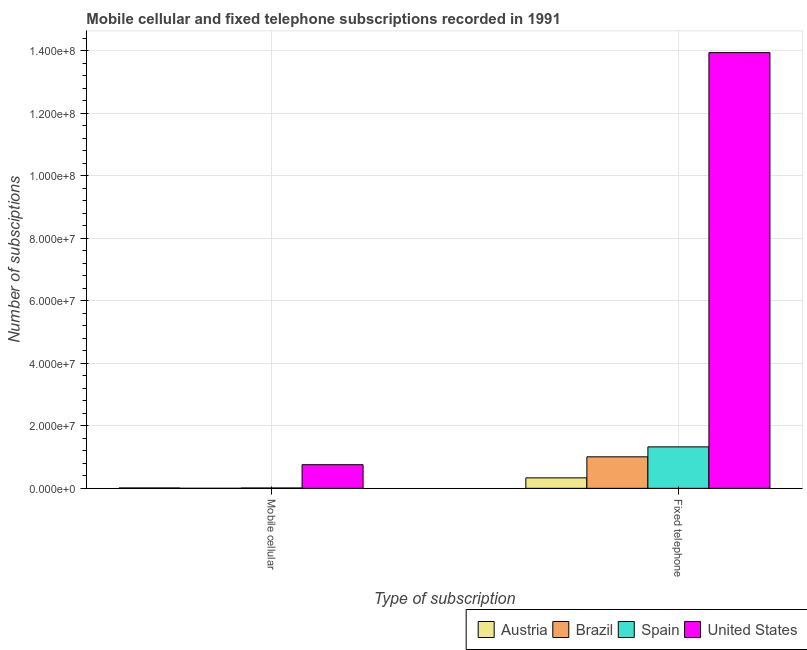Are the number of bars per tick equal to the number of legend labels?
Provide a short and direct response. Yes. Are the number of bars on each tick of the X-axis equal?
Your answer should be very brief. Yes. How many bars are there on the 2nd tick from the left?
Ensure brevity in your answer.  4. What is the label of the 1st group of bars from the left?
Offer a very short reply. Mobile cellular. What is the number of fixed telephone subscriptions in United States?
Your answer should be compact. 1.39e+08. Across all countries, what is the maximum number of fixed telephone subscriptions?
Your response must be concise. 1.39e+08. Across all countries, what is the minimum number of fixed telephone subscriptions?
Ensure brevity in your answer.  3.34e+06. In which country was the number of mobile cellular subscriptions maximum?
Make the answer very short. United States. In which country was the number of fixed telephone subscriptions minimum?
Provide a succinct answer. Austria. What is the total number of fixed telephone subscriptions in the graph?
Provide a short and direct response. 1.66e+08. What is the difference between the number of fixed telephone subscriptions in Austria and that in United States?
Give a very brief answer. -1.36e+08. What is the difference between the number of fixed telephone subscriptions in Spain and the number of mobile cellular subscriptions in United States?
Provide a succinct answer. 5.71e+06. What is the average number of mobile cellular subscriptions per country?
Keep it short and to the point. 1.95e+06. What is the difference between the number of mobile cellular subscriptions and number of fixed telephone subscriptions in United States?
Your response must be concise. -1.32e+08. What is the ratio of the number of fixed telephone subscriptions in Spain to that in Brazil?
Make the answer very short. 1.32. What does the 4th bar from the right in Fixed telephone represents?
Your answer should be very brief. Austria. How many countries are there in the graph?
Keep it short and to the point. 4. Does the graph contain any zero values?
Offer a terse response. No. How many legend labels are there?
Make the answer very short. 4. How are the legend labels stacked?
Make the answer very short. Horizontal. What is the title of the graph?
Your answer should be very brief. Mobile cellular and fixed telephone subscriptions recorded in 1991. Does "Brunei Darussalam" appear as one of the legend labels in the graph?
Your response must be concise. No. What is the label or title of the X-axis?
Provide a short and direct response. Type of subscription. What is the label or title of the Y-axis?
Give a very brief answer. Number of subsciptions. What is the Number of subsciptions in Austria in Mobile cellular?
Your answer should be compact. 1.15e+05. What is the Number of subsciptions of Brazil in Mobile cellular?
Ensure brevity in your answer.  6700. What is the Number of subsciptions in Spain in Mobile cellular?
Give a very brief answer. 1.08e+05. What is the Number of subsciptions of United States in Mobile cellular?
Provide a short and direct response. 7.56e+06. What is the Number of subsciptions of Austria in Fixed telephone?
Give a very brief answer. 3.34e+06. What is the Number of subsciptions of Brazil in Fixed telephone?
Ensure brevity in your answer.  1.01e+07. What is the Number of subsciptions in Spain in Fixed telephone?
Your answer should be compact. 1.33e+07. What is the Number of subsciptions in United States in Fixed telephone?
Your answer should be compact. 1.39e+08. Across all Type of subscription, what is the maximum Number of subsciptions in Austria?
Provide a short and direct response. 3.34e+06. Across all Type of subscription, what is the maximum Number of subsciptions in Brazil?
Provide a succinct answer. 1.01e+07. Across all Type of subscription, what is the maximum Number of subsciptions of Spain?
Your answer should be very brief. 1.33e+07. Across all Type of subscription, what is the maximum Number of subsciptions of United States?
Make the answer very short. 1.39e+08. Across all Type of subscription, what is the minimum Number of subsciptions in Austria?
Keep it short and to the point. 1.15e+05. Across all Type of subscription, what is the minimum Number of subsciptions of Brazil?
Make the answer very short. 6700. Across all Type of subscription, what is the minimum Number of subsciptions in Spain?
Provide a succinct answer. 1.08e+05. Across all Type of subscription, what is the minimum Number of subsciptions in United States?
Your answer should be very brief. 7.56e+06. What is the total Number of subsciptions in Austria in the graph?
Offer a terse response. 3.46e+06. What is the total Number of subsciptions in Brazil in the graph?
Your response must be concise. 1.01e+07. What is the total Number of subsciptions in Spain in the graph?
Provide a succinct answer. 1.34e+07. What is the total Number of subsciptions of United States in the graph?
Ensure brevity in your answer.  1.47e+08. What is the difference between the Number of subsciptions of Austria in Mobile cellular and that in Fixed telephone?
Your response must be concise. -3.23e+06. What is the difference between the Number of subsciptions of Brazil in Mobile cellular and that in Fixed telephone?
Your answer should be very brief. -1.01e+07. What is the difference between the Number of subsciptions of Spain in Mobile cellular and that in Fixed telephone?
Offer a very short reply. -1.32e+07. What is the difference between the Number of subsciptions in United States in Mobile cellular and that in Fixed telephone?
Your response must be concise. -1.32e+08. What is the difference between the Number of subsciptions in Austria in Mobile cellular and the Number of subsciptions in Brazil in Fixed telephone?
Provide a succinct answer. -9.96e+06. What is the difference between the Number of subsciptions of Austria in Mobile cellular and the Number of subsciptions of Spain in Fixed telephone?
Give a very brief answer. -1.31e+07. What is the difference between the Number of subsciptions in Austria in Mobile cellular and the Number of subsciptions in United States in Fixed telephone?
Offer a terse response. -1.39e+08. What is the difference between the Number of subsciptions in Brazil in Mobile cellular and the Number of subsciptions in Spain in Fixed telephone?
Your answer should be very brief. -1.33e+07. What is the difference between the Number of subsciptions of Brazil in Mobile cellular and the Number of subsciptions of United States in Fixed telephone?
Ensure brevity in your answer.  -1.39e+08. What is the difference between the Number of subsciptions of Spain in Mobile cellular and the Number of subsciptions of United States in Fixed telephone?
Your response must be concise. -1.39e+08. What is the average Number of subsciptions of Austria per Type of subscription?
Your response must be concise. 1.73e+06. What is the average Number of subsciptions in Brazil per Type of subscription?
Keep it short and to the point. 5.04e+06. What is the average Number of subsciptions in Spain per Type of subscription?
Your response must be concise. 6.69e+06. What is the average Number of subsciptions in United States per Type of subscription?
Your answer should be compact. 7.35e+07. What is the difference between the Number of subsciptions of Austria and Number of subsciptions of Brazil in Mobile cellular?
Provide a succinct answer. 1.09e+05. What is the difference between the Number of subsciptions of Austria and Number of subsciptions of Spain in Mobile cellular?
Give a very brief answer. 6951. What is the difference between the Number of subsciptions of Austria and Number of subsciptions of United States in Mobile cellular?
Make the answer very short. -7.44e+06. What is the difference between the Number of subsciptions in Brazil and Number of subsciptions in Spain in Mobile cellular?
Keep it short and to the point. -1.02e+05. What is the difference between the Number of subsciptions in Brazil and Number of subsciptions in United States in Mobile cellular?
Offer a terse response. -7.55e+06. What is the difference between the Number of subsciptions in Spain and Number of subsciptions in United States in Mobile cellular?
Offer a very short reply. -7.45e+06. What is the difference between the Number of subsciptions of Austria and Number of subsciptions of Brazil in Fixed telephone?
Your response must be concise. -6.73e+06. What is the difference between the Number of subsciptions of Austria and Number of subsciptions of Spain in Fixed telephone?
Your answer should be compact. -9.92e+06. What is the difference between the Number of subsciptions in Austria and Number of subsciptions in United States in Fixed telephone?
Your answer should be very brief. -1.36e+08. What is the difference between the Number of subsciptions in Brazil and Number of subsciptions in Spain in Fixed telephone?
Your answer should be compact. -3.19e+06. What is the difference between the Number of subsciptions of Brazil and Number of subsciptions of United States in Fixed telephone?
Ensure brevity in your answer.  -1.29e+08. What is the difference between the Number of subsciptions of Spain and Number of subsciptions of United States in Fixed telephone?
Offer a terse response. -1.26e+08. What is the ratio of the Number of subsciptions in Austria in Mobile cellular to that in Fixed telephone?
Your answer should be compact. 0.03. What is the ratio of the Number of subsciptions of Brazil in Mobile cellular to that in Fixed telephone?
Offer a terse response. 0. What is the ratio of the Number of subsciptions in Spain in Mobile cellular to that in Fixed telephone?
Your answer should be very brief. 0.01. What is the ratio of the Number of subsciptions in United States in Mobile cellular to that in Fixed telephone?
Provide a succinct answer. 0.05. What is the difference between the highest and the second highest Number of subsciptions in Austria?
Ensure brevity in your answer.  3.23e+06. What is the difference between the highest and the second highest Number of subsciptions of Brazil?
Ensure brevity in your answer.  1.01e+07. What is the difference between the highest and the second highest Number of subsciptions in Spain?
Your answer should be very brief. 1.32e+07. What is the difference between the highest and the second highest Number of subsciptions in United States?
Keep it short and to the point. 1.32e+08. What is the difference between the highest and the lowest Number of subsciptions in Austria?
Provide a succinct answer. 3.23e+06. What is the difference between the highest and the lowest Number of subsciptions of Brazil?
Your answer should be compact. 1.01e+07. What is the difference between the highest and the lowest Number of subsciptions of Spain?
Your response must be concise. 1.32e+07. What is the difference between the highest and the lowest Number of subsciptions of United States?
Ensure brevity in your answer.  1.32e+08. 